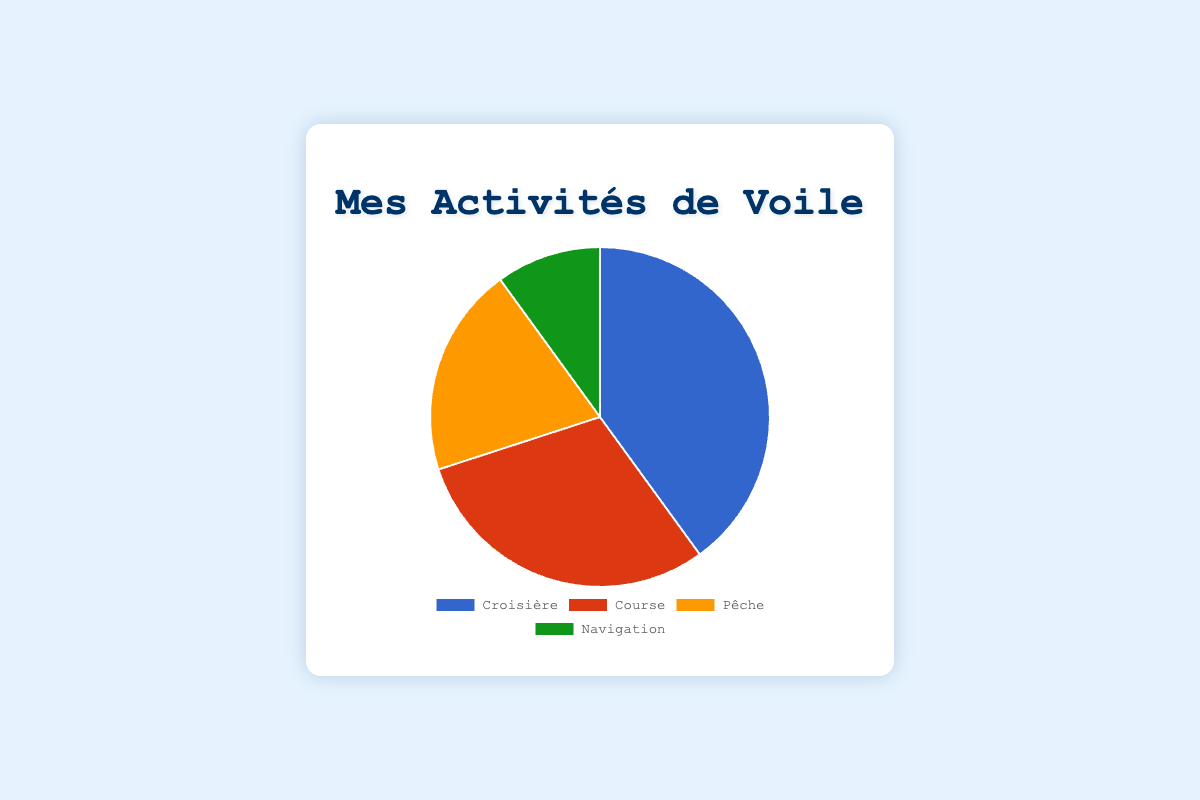What's the percentage of time spent on Cruising? The activity labeled 'Croisière' (Cruising) has a percentage value next to it.
Answer: 40% Which activity has the smallest percentage of time spent? Compare all four percentage values (40%, 30%, 20%, 10%). The smallest value among them is 10%.
Answer: Navigating How much more time is spent Racing compared to Fishing, in percentage? 'Racing' has 30% and 'Fishing' has 20%. Subtract the smaller percentage from the larger one (30% - 20%).
Answer: 10% What two activities together account for half of the total time spent? Calculate percentages of all pairs: (Cruising + Fishing = 40% + 20% = 60%), (Racing + Navigating = 30% + 10% = 40%), etc. The pair that adds up to 50% is 'Racing' and 'Fishing' (30% + 20%).
Answer: Racing and Fishing If you combined the time spent on Racing and Navigating, what would the new percentage be? Add the percentages for 'Racing' and 'Navigating' (30% + 10%)
Answer: 40% Which activity represents 1/5 of the total time spent? Convert 1/5 into a percentage (20%) and find the corresponding activity.
Answer: Fishing Is more time spent Cruise sailing or Navigating? Compare the percentages: 'Cruising' (40%) and 'Navigating' (10%). 40% > 10%.
Answer: Cruising Which two activities together represent 70% of the total time spent? Compare pairs of activities: (Cruising + Racing = 40% + 30% = 70%)
Answer: Cruising and Racing What is the average percentage of time spent on all activities? Sum all percentages and divide by the number of activities: (40% + 30% + 20% + 10%) / 4
Answer: 25% Which activity has the largest visual segment on the pie chart? The largest segment corresponds to the highest percentage value, which is 40%.
Answer: Cruising 